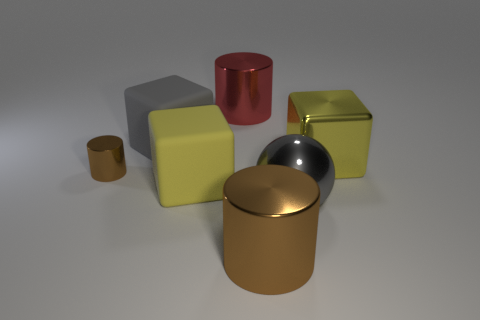Subtract all yellow metal cubes. How many cubes are left? 2 Add 2 tiny blue rubber blocks. How many objects exist? 9 Subtract all cylinders. How many objects are left? 4 Subtract all gray blocks. How many blocks are left? 2 Subtract all cylinders. Subtract all brown objects. How many objects are left? 2 Add 5 big yellow metal blocks. How many big yellow metal blocks are left? 6 Add 5 big yellow blocks. How many big yellow blocks exist? 7 Subtract 0 green cubes. How many objects are left? 7 Subtract 1 cylinders. How many cylinders are left? 2 Subtract all red cylinders. Subtract all cyan balls. How many cylinders are left? 2 